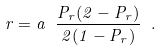<formula> <loc_0><loc_0><loc_500><loc_500>r = a \ \frac { P _ { r } ( 2 - P _ { r } ) } { 2 ( 1 - P _ { r } ) } \ .</formula> 